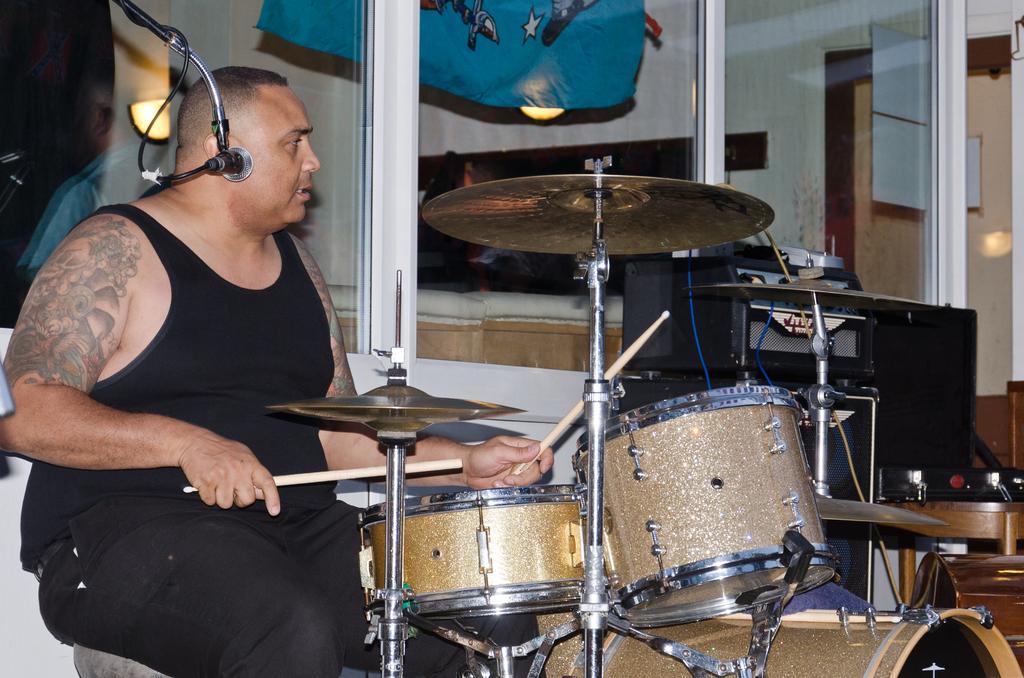How would you summarize this image in a sentence or two? In the foreground I can see a person is playing musical instruments on the floor. In the background I can see a glass, window, cloth, door and so on. This image is taken may be in a room. 